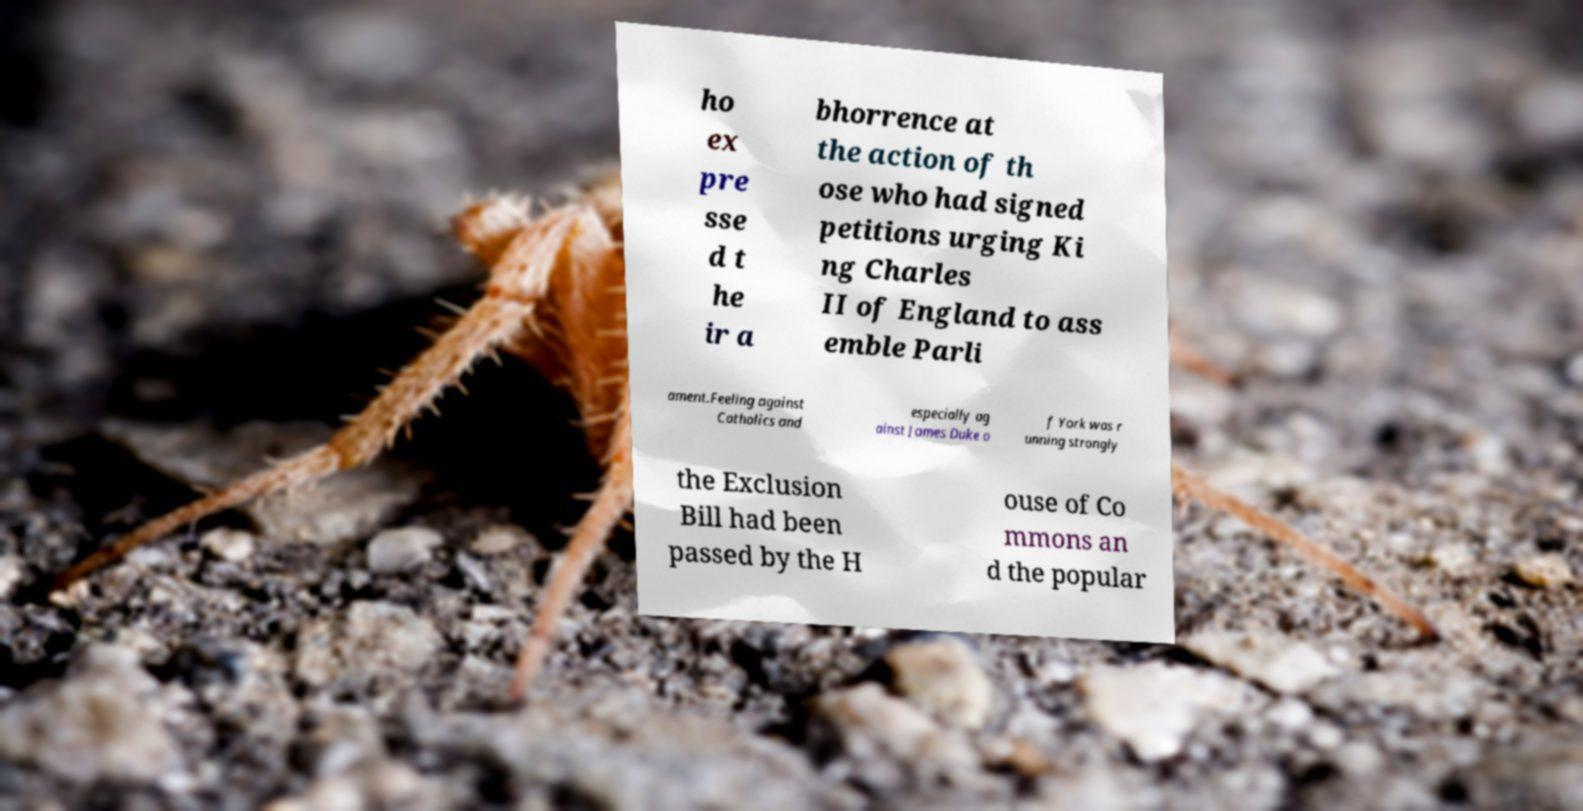For documentation purposes, I need the text within this image transcribed. Could you provide that? ho ex pre sse d t he ir a bhorrence at the action of th ose who had signed petitions urging Ki ng Charles II of England to ass emble Parli ament.Feeling against Catholics and especially ag ainst James Duke o f York was r unning strongly the Exclusion Bill had been passed by the H ouse of Co mmons an d the popular 